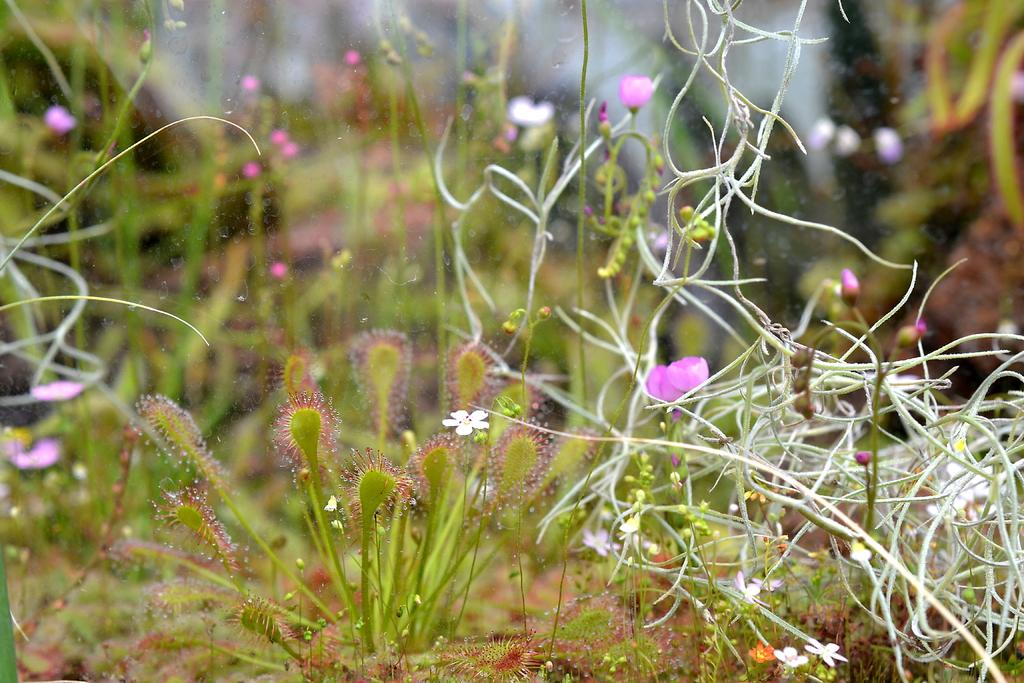What is the primary subject of the image? The primary subject of the image is many plants. What can be observed on the plants in the image? There are many flowers on the plants in the image. Where is the picture of the library with cherries hanging from the shelves in the image? There is no picture of a library with cherries hanging from the shelves present in the image. 